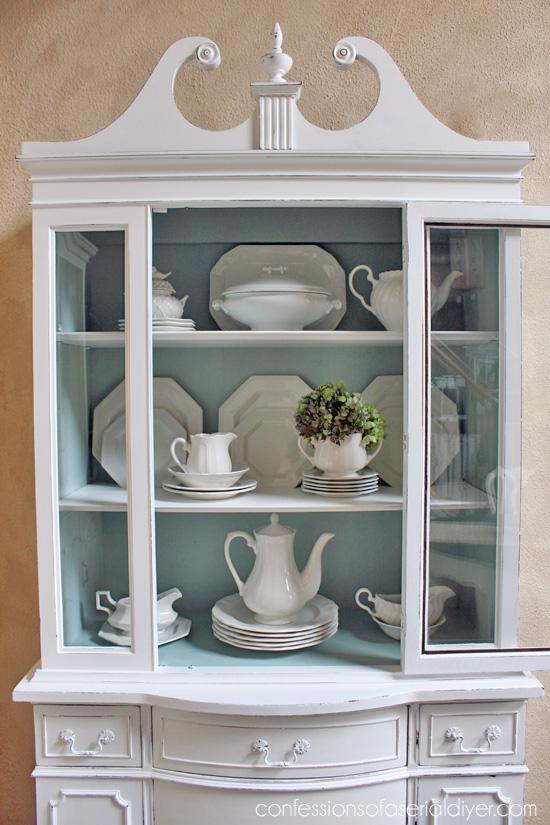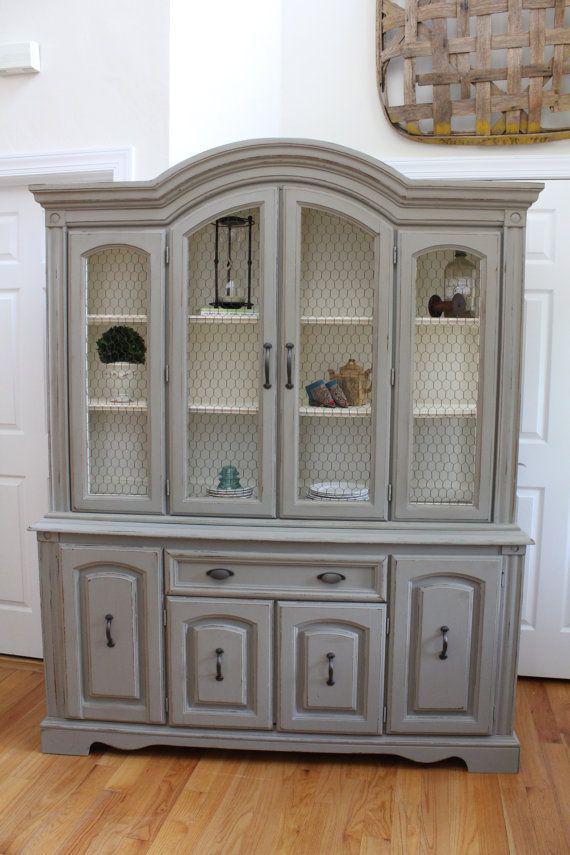The first image is the image on the left, the second image is the image on the right. Examine the images to the left and right. Is the description "One cabinet has a white exterior and a front that is not flat, with curving drawers under the display hutch top." accurate? Answer yes or no. Yes. The first image is the image on the left, the second image is the image on the right. Considering the images on both sides, is "The cabinet in the image on the right is not a square shape." valid? Answer yes or no. Yes. 